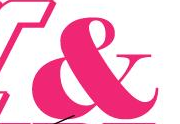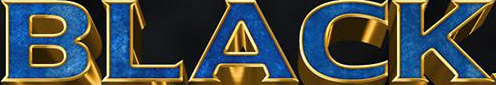Transcribe the words shown in these images in order, separated by a semicolon. &; BLACK 